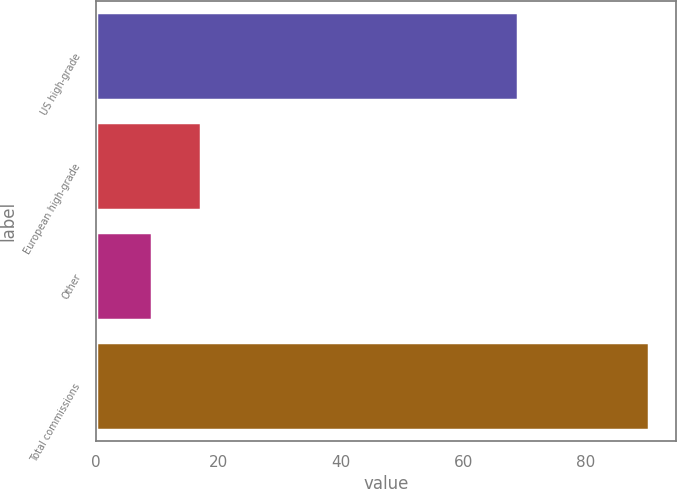Convert chart to OTSL. <chart><loc_0><loc_0><loc_500><loc_500><bar_chart><fcel>US high-grade<fcel>European high-grade<fcel>Other<fcel>Total commissions<nl><fcel>69<fcel>17.22<fcel>9.1<fcel>90.3<nl></chart> 